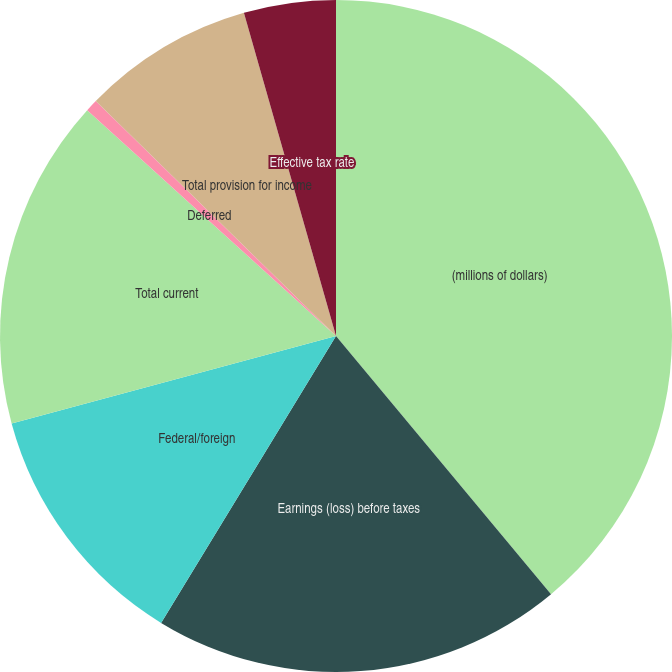Convert chart. <chart><loc_0><loc_0><loc_500><loc_500><pie_chart><fcel>(millions of dollars)<fcel>Earnings (loss) before taxes<fcel>Federal/foreign<fcel>Total current<fcel>Deferred<fcel>Total provision for income<fcel>Effective tax rate<nl><fcel>38.95%<fcel>19.77%<fcel>12.09%<fcel>15.93%<fcel>0.59%<fcel>8.26%<fcel>4.42%<nl></chart> 